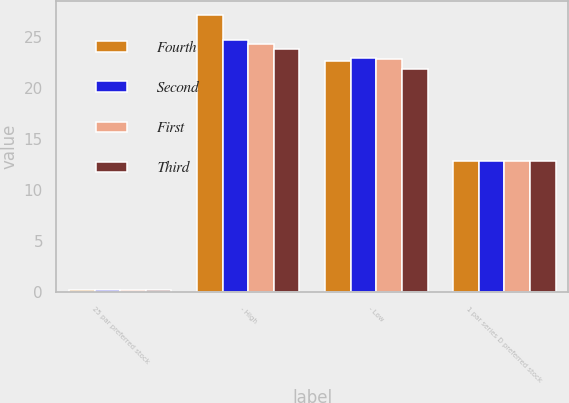<chart> <loc_0><loc_0><loc_500><loc_500><stacked_bar_chart><ecel><fcel>25 par preferred stock<fcel>- High<fcel>- Low<fcel>1 par series D preferred stock<nl><fcel>Fourth<fcel>0.25<fcel>27.17<fcel>22.61<fcel>12.81<nl><fcel>Second<fcel>0.25<fcel>24.74<fcel>22.9<fcel>12.81<nl><fcel>First<fcel>0.25<fcel>24.31<fcel>22.85<fcel>12.81<nl><fcel>Third<fcel>0.25<fcel>23.85<fcel>21.87<fcel>12.81<nl></chart> 